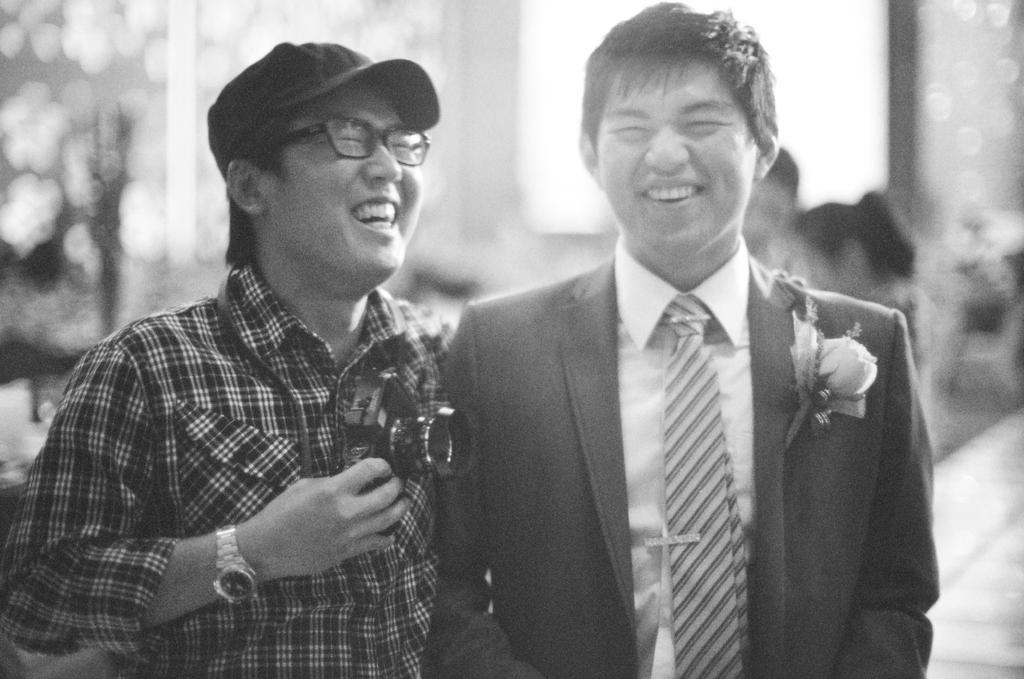Describe this image in one or two sentences. As we can see in the image in the front there are two persons standing. The man standing on the left side is wearing black color shirt and holding camera. The man standing on the right side is wearing black color jacket. The background is little blurred. 